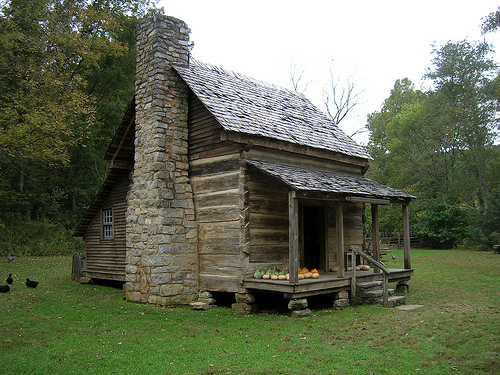<image>
Is the window in the chimney? No. The window is not contained within the chimney. These objects have a different spatial relationship. 